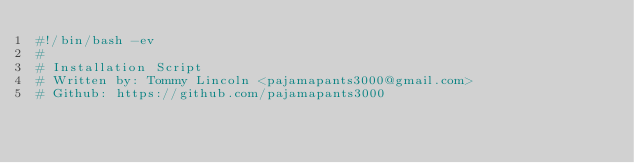Convert code to text. <code><loc_0><loc_0><loc_500><loc_500><_Bash_>#!/bin/bash -ev
#
# Installation Script
# Written by: Tommy Lincoln <pajamapants3000@gmail.com>
# Github: https://github.com/pajamapants3000</code> 